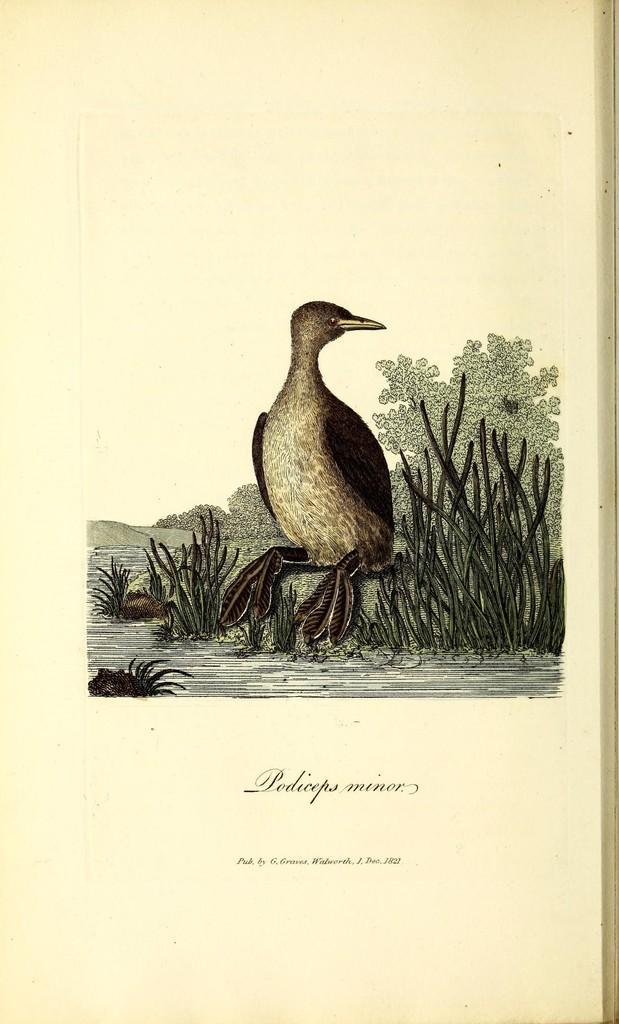How would you summarize this image in a sentence or two? In the image I can see painting of a bird, the grass, trees, the water and also I can see something written on the image. 